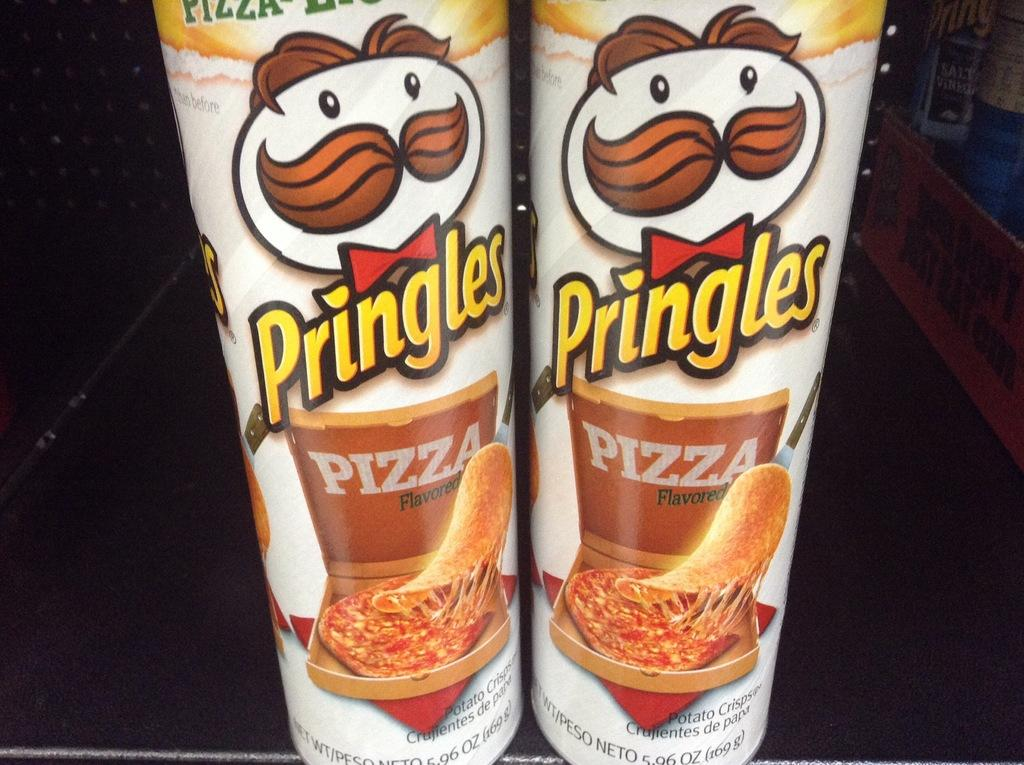How many bottles are visible in the image? There are two bottles in the image. What can be found on the bottles besides the images? There is writing on the bottles. What else is depicted on the bottles besides text? There are images on the bottles. How many sisters are depicted on the bottles? There are no sisters depicted on the bottles; they only have writing and images on them. What type of card is shown on the bottles? There is no card present on the bottles; they only have writing and images on them. 